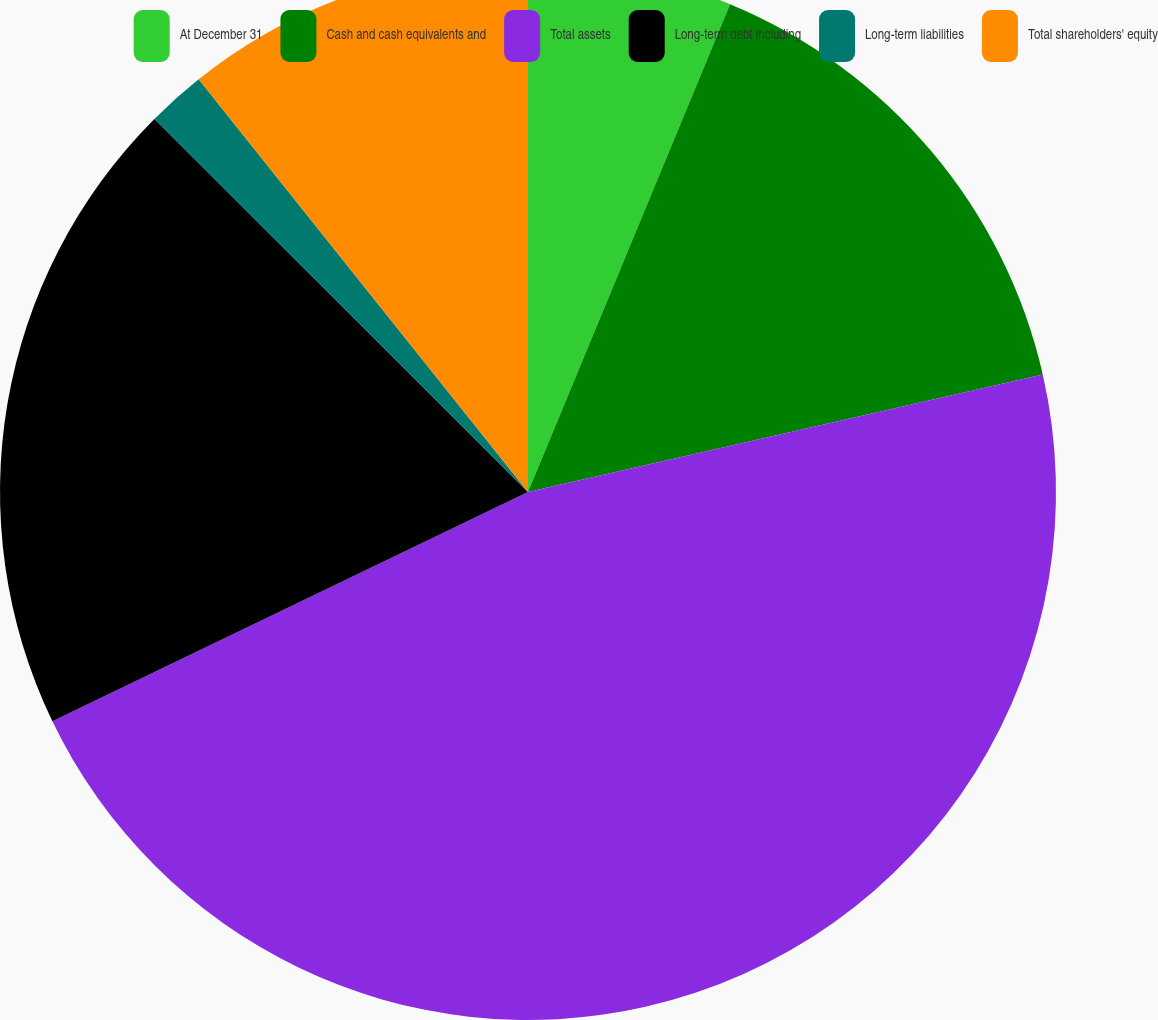<chart> <loc_0><loc_0><loc_500><loc_500><pie_chart><fcel>At December 31<fcel>Cash and cash equivalents and<fcel>Total assets<fcel>Long-term debt including<fcel>Long-term liabilities<fcel>Total shareholders' equity<nl><fcel>6.25%<fcel>15.18%<fcel>46.42%<fcel>19.64%<fcel>1.79%<fcel>10.72%<nl></chart> 